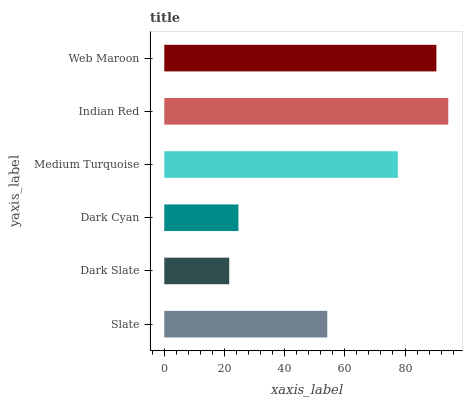Is Dark Slate the minimum?
Answer yes or no. Yes. Is Indian Red the maximum?
Answer yes or no. Yes. Is Dark Cyan the minimum?
Answer yes or no. No. Is Dark Cyan the maximum?
Answer yes or no. No. Is Dark Cyan greater than Dark Slate?
Answer yes or no. Yes. Is Dark Slate less than Dark Cyan?
Answer yes or no. Yes. Is Dark Slate greater than Dark Cyan?
Answer yes or no. No. Is Dark Cyan less than Dark Slate?
Answer yes or no. No. Is Medium Turquoise the high median?
Answer yes or no. Yes. Is Slate the low median?
Answer yes or no. Yes. Is Dark Slate the high median?
Answer yes or no. No. Is Dark Slate the low median?
Answer yes or no. No. 